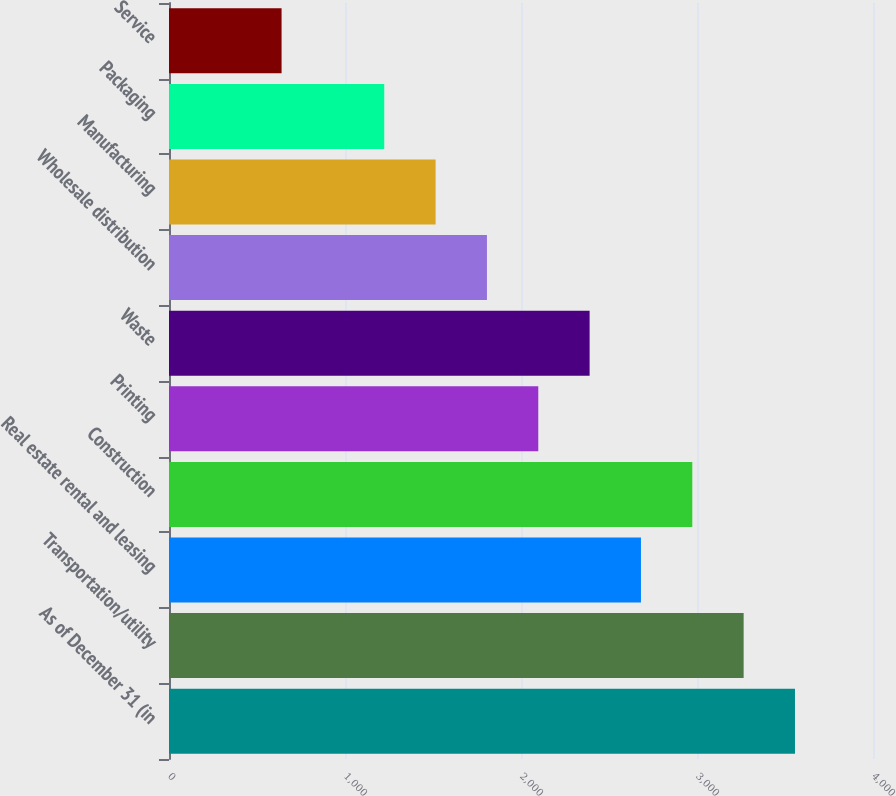<chart> <loc_0><loc_0><loc_500><loc_500><bar_chart><fcel>As of December 31 (in<fcel>Transportation/utility<fcel>Real estate rental and leasing<fcel>Construction<fcel>Printing<fcel>Waste<fcel>Wholesale distribution<fcel>Manufacturing<fcel>Packaging<fcel>Service<nl><fcel>3556.72<fcel>3265.01<fcel>2681.59<fcel>2973.3<fcel>2098.17<fcel>2389.88<fcel>1806.46<fcel>1514.75<fcel>1223.04<fcel>639.62<nl></chart> 